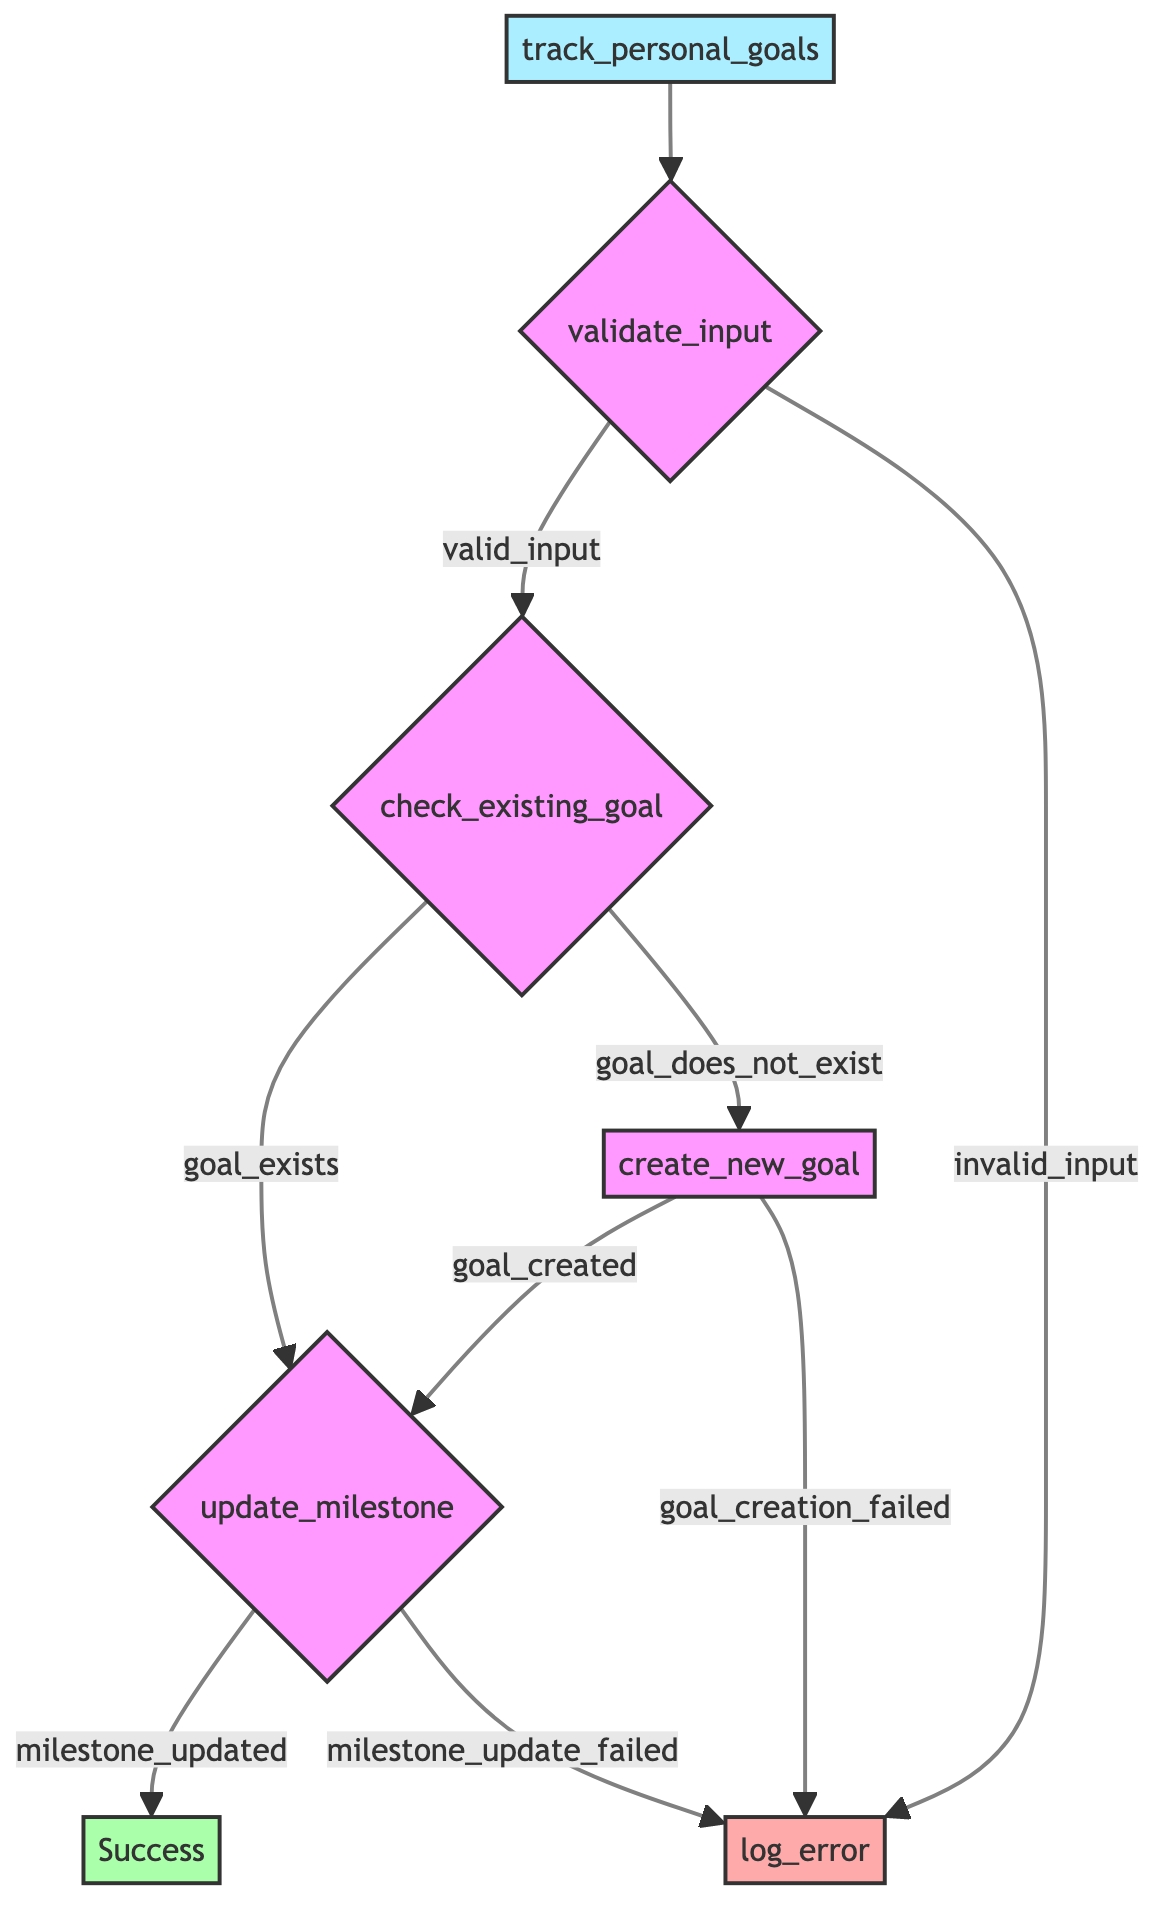What is the first operation in the flowchart? The flowchart begins with the operation labeled "validate_input". This is indicated by the first arrow stemming from the main function node "track_personal_goals" pointing to the decision node "validate_input".
Answer: validate_input How many outcomes can result from the "validate_input" step? The result of the "validate_input" step can lead to two outcomes: "valid_input" and "invalid_input". This is shown directly as branches from the "validate_input" node.
Answer: two What happens if the "goal_name" already exists? If the "goal_name" already exists, the flow proceeds to the step "update_milestone". This is derived from the branch labeled "goal_exists" connected to the "check_existing_goal" node.
Answer: update_milestone What is the dependence of the "create_new_goal" operation? The "create_new_goal" operation depends on the outcome of "goal_does_not_exist". This relationship is established by the arrow leading from the "goal_does_not_exist" outcome to the "create_new_goal" node.
Answer: goal_does_not_exist What is logged if the "milestone_update_failed"? If "milestone_update_failed" occurs, the flowchart indicates that the operation "log_error" will be executed. This is a direct result of the branching in the "update_milestone" node leading to "log_error".
Answer: log_error What is the final outcome if all inputs are valid and the goal is created? If all inputs are valid and the goal is successfully created, the flowchart concludes with "Success". This outcome follows the path through "validate_input", "check_existing_goal", "create_new_goal", and then "update_milestone".
Answer: Success How many steps are there in total in the flowchart? Counting the nodes in the flowchart, there are a total of six steps: "validate_input", "check_existing_goal", "create_new_goal", "update_milestone", "log_error", and "Success".
Answer: six What is the purpose of the "log_error" operation? The purpose of the "log_error" operation is to record errors for further action when any previous step fails. This is indicated in the flowchart where "log_error" is connected to multiple failure outcomes.
Answer: record errors What are the parameter inputs for the function "track_personal_goals"? The parameters for the function "track_personal_goals" are "goal_name", "milestone_name", and "current_status". These are listed in the initial definition of the function.
Answer: goal_name, milestone_name, current_status 